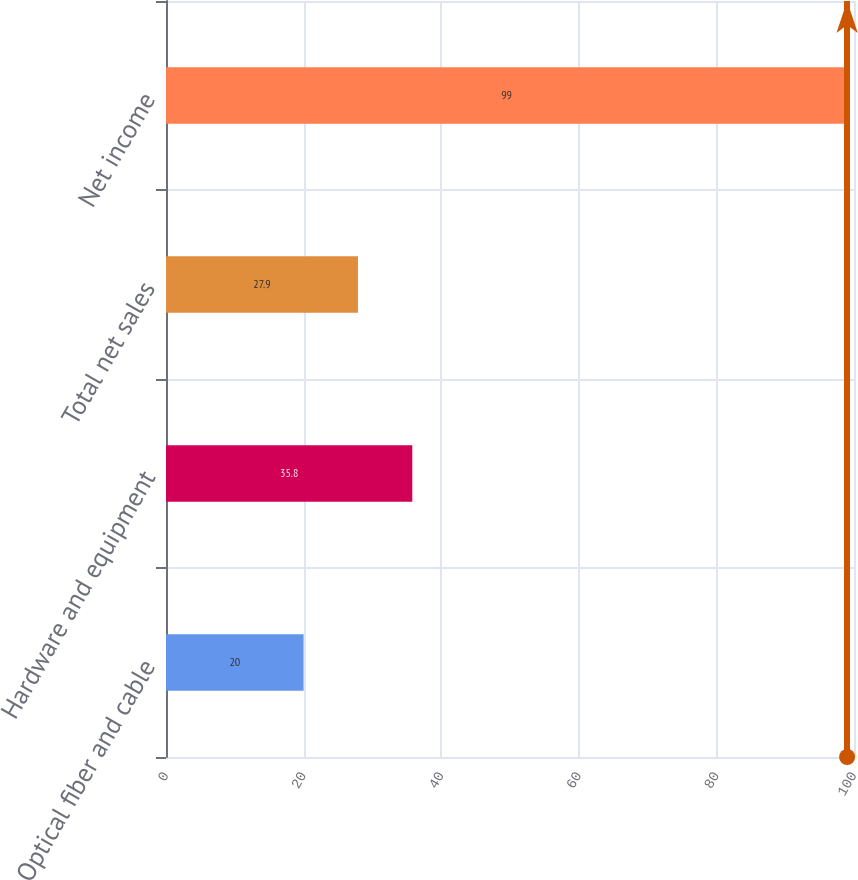Convert chart. <chart><loc_0><loc_0><loc_500><loc_500><bar_chart><fcel>Optical fiber and cable<fcel>Hardware and equipment<fcel>Total net sales<fcel>Net income<nl><fcel>20<fcel>35.8<fcel>27.9<fcel>99<nl></chart> 